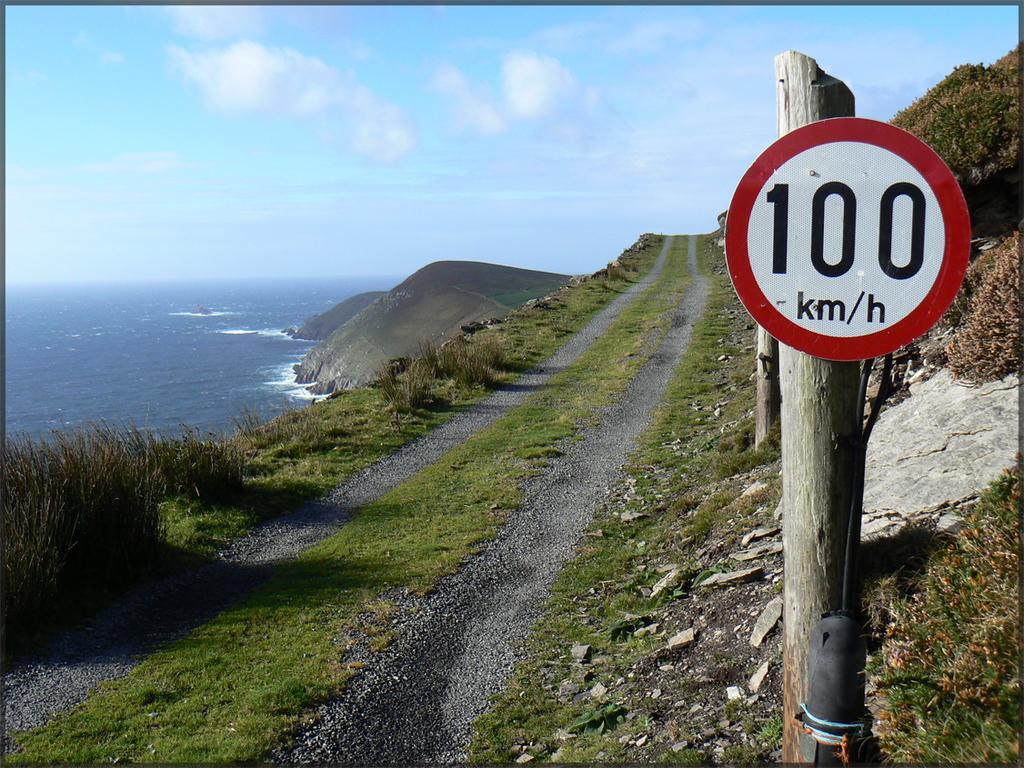<image>
Render a clear and concise summary of the photo. A narrow cliffside road has a speed limit of 100 km per hour. 